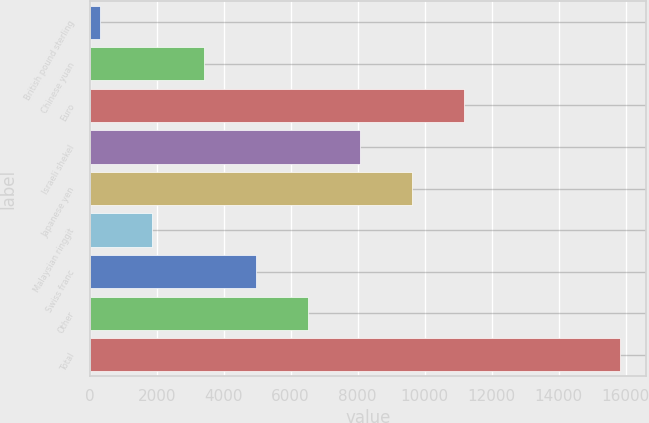Convert chart. <chart><loc_0><loc_0><loc_500><loc_500><bar_chart><fcel>British pound sterling<fcel>Chinese yuan<fcel>Euro<fcel>Israeli shekel<fcel>Japanese yen<fcel>Malaysian ringgit<fcel>Swiss franc<fcel>Other<fcel>Total<nl><fcel>308<fcel>3412<fcel>11172<fcel>8068<fcel>9620<fcel>1860<fcel>4964<fcel>6516<fcel>15828<nl></chart> 